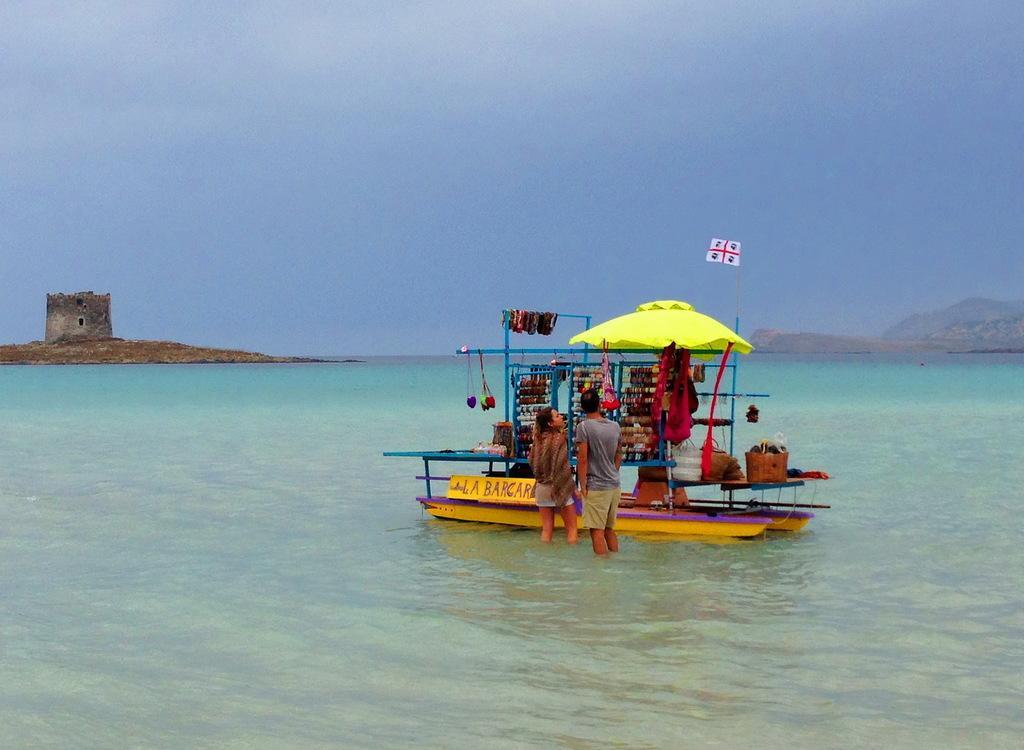Can you describe this image briefly? This image is taken outdoors. At the top of the image there is the sky with clouds. In the background there are a few hills and there is a hurt on the ground. In the middle of the image there is a stall in the boat. There are a few bangles, a few bags, scarves and a few things on the table and hangers and there is an umbrella. A man and a woman are standing in the sea. At the bottom of the image there is a sea with water. 